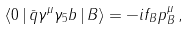Convert formula to latex. <formula><loc_0><loc_0><loc_500><loc_500>\langle 0 \, | \, \bar { q } \gamma ^ { \mu } \gamma _ { 5 } b \, | \, B \rangle = - i f _ { B } p _ { B } ^ { \mu } \, ,</formula> 